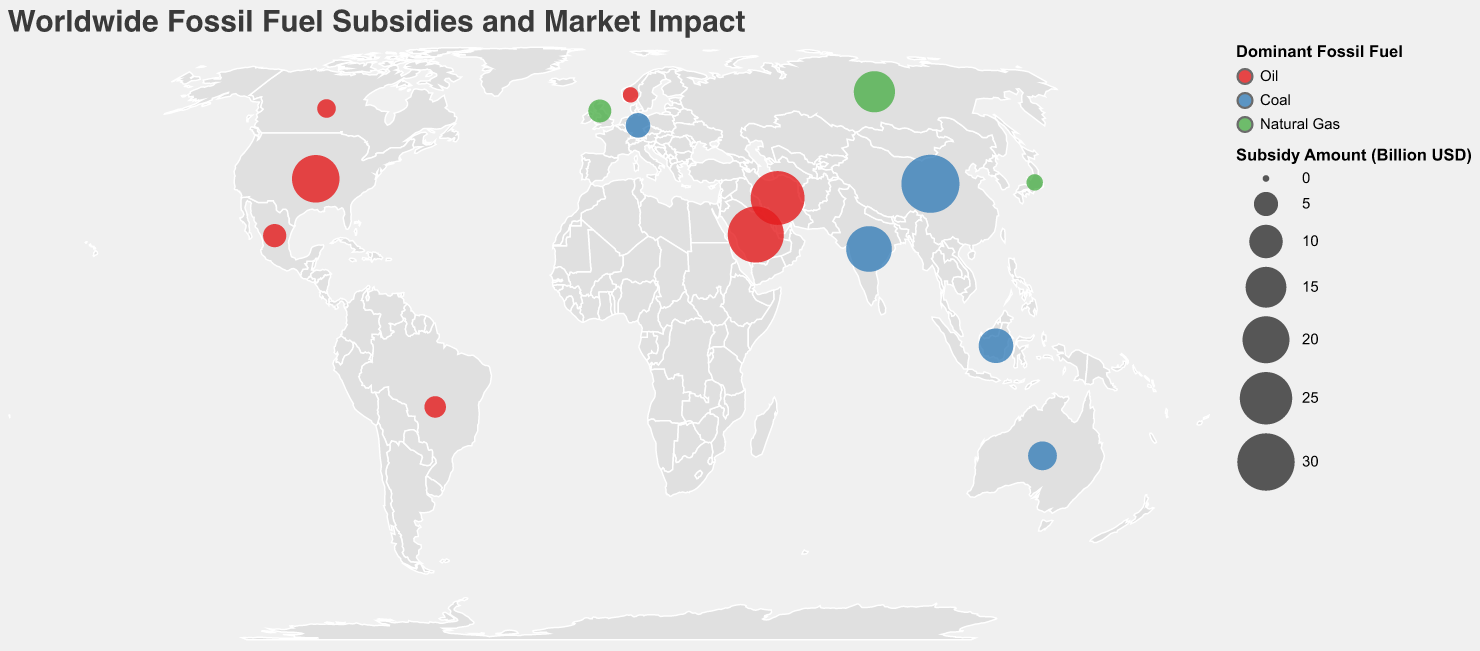What is the title of the figure? The title is displayed at the top of the figure. It reads "Worldwide Fossil Fuel Subsidies and Market Impact".
Answer: Worldwide Fossil Fuel Subsidies and Market Impact Which country has the highest fossil fuel subsidy amount? Looking at the size of circles, the biggest circle represents the highest subsidy amount. China has the largest circle, corresponding to $30.8 billion USD.
Answer: China Which dominant fossil fuel type is represented by the color red in the figure? The legend indicates that the color red corresponds to "Oil".
Answer: Oil What is the subsidy amount for India? Hovering over the circle for India or looking at the tooltip, the subsidy amount is shown as $18.9 billion USD.
Answer: $18.9 billion USD Which country has the lowest market impact score, and what is the score? By inspecting the tooltip or size of circles, Norway has the lowest market impact score at 2.9.
Answer: Norway, 2.9 What is the total subsidy amount for countries where the dominant fossil fuel is coal? Sum the subsidies for China (30.8), Germany (5.2), India (18.9), Indonesia (10.7), and Australia (7.3): 30.8 + 5.2 + 18.9 + 10.7 + 7.3 = 72.9 billion USD.
Answer: 72.9 billion USD Which country with oil as its dominant fossil fuel has the second highest subsidy amount? From the circles colored red, Saudi Arabia has the second largest circle corresponding to $28.7 billion USD, after China.
Answer: Saudi Arabia Are there any countries with a subsidy amount below $5 billion USD? If so, which ones? Look for smaller circles or refer to the tooltip. Countries are Germany (5.2), Canada (2.8), Mexico (4.6), Japan (2.1), Brazil (3.9), the United Kingdom (4.5), and Norway (1.8). Except for Germany and the UK, the others have subsidies below $5 billion USD.
Answer: Canada, Mexico, Japan, Brazil, Norway Which two countries have the closest market impact scores, and what are they? Comparing market impact scores, Mexico (4.8) and the United Kingdom (4.7) have the closest scores with a difference of 0.1.
Answer: Mexico and the United Kingdom How many countries have natural gas as their dominant fossil fuel? Checking the legend and corresponding colors, natural gas is represented in Russia, Japan, and the United Kingdom. Count these countries.
Answer: 3 